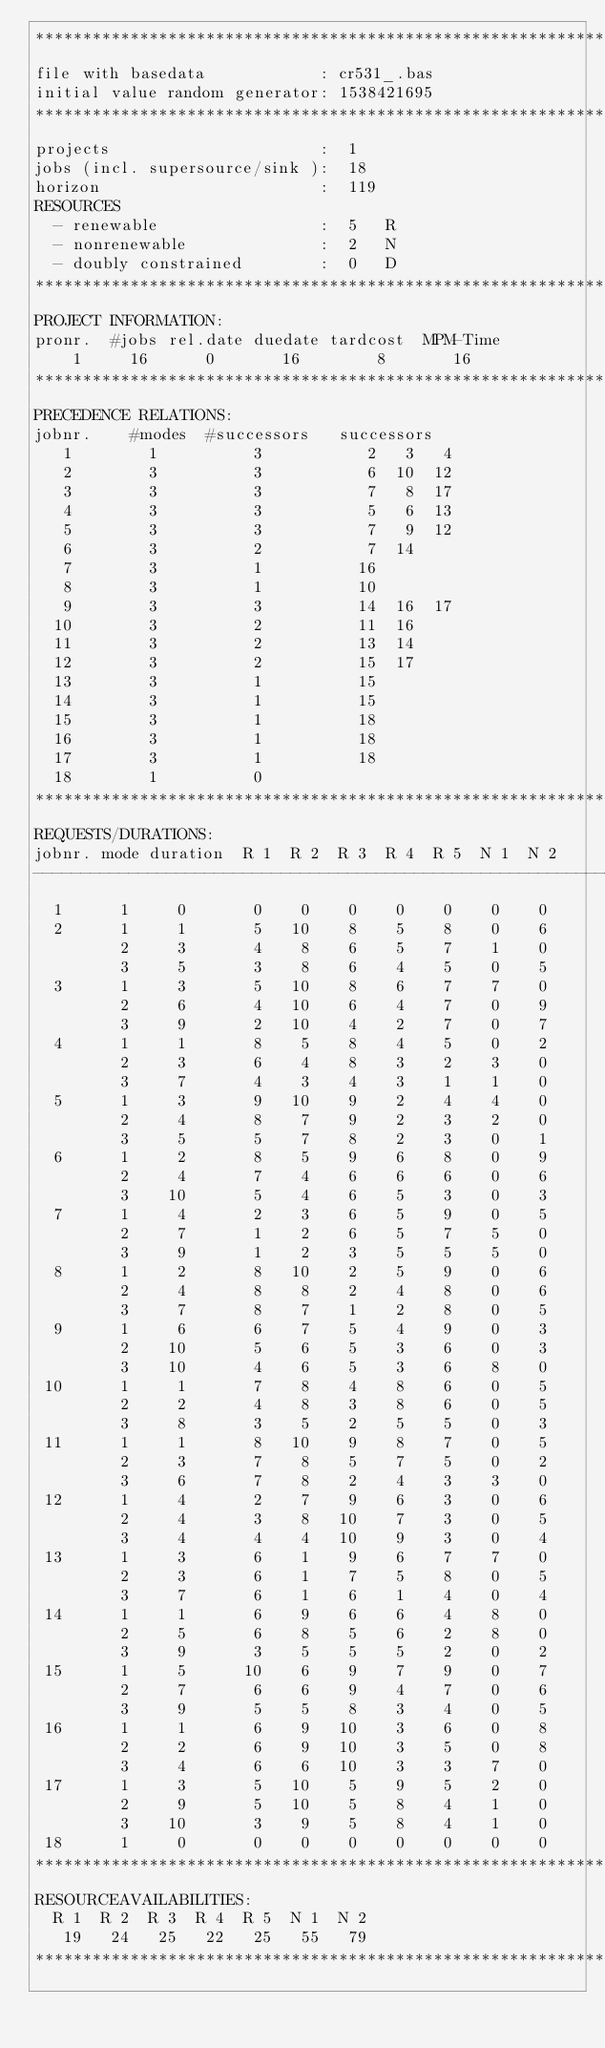Convert code to text. <code><loc_0><loc_0><loc_500><loc_500><_ObjectiveC_>************************************************************************
file with basedata            : cr531_.bas
initial value random generator: 1538421695
************************************************************************
projects                      :  1
jobs (incl. supersource/sink ):  18
horizon                       :  119
RESOURCES
  - renewable                 :  5   R
  - nonrenewable              :  2   N
  - doubly constrained        :  0   D
************************************************************************
PROJECT INFORMATION:
pronr.  #jobs rel.date duedate tardcost  MPM-Time
    1     16      0       16        8       16
************************************************************************
PRECEDENCE RELATIONS:
jobnr.    #modes  #successors   successors
   1        1          3           2   3   4
   2        3          3           6  10  12
   3        3          3           7   8  17
   4        3          3           5   6  13
   5        3          3           7   9  12
   6        3          2           7  14
   7        3          1          16
   8        3          1          10
   9        3          3          14  16  17
  10        3          2          11  16
  11        3          2          13  14
  12        3          2          15  17
  13        3          1          15
  14        3          1          15
  15        3          1          18
  16        3          1          18
  17        3          1          18
  18        1          0        
************************************************************************
REQUESTS/DURATIONS:
jobnr. mode duration  R 1  R 2  R 3  R 4  R 5  N 1  N 2
------------------------------------------------------------------------
  1      1     0       0    0    0    0    0    0    0
  2      1     1       5   10    8    5    8    0    6
         2     3       4    8    6    5    7    1    0
         3     5       3    8    6    4    5    0    5
  3      1     3       5   10    8    6    7    7    0
         2     6       4   10    6    4    7    0    9
         3     9       2   10    4    2    7    0    7
  4      1     1       8    5    8    4    5    0    2
         2     3       6    4    8    3    2    3    0
         3     7       4    3    4    3    1    1    0
  5      1     3       9   10    9    2    4    4    0
         2     4       8    7    9    2    3    2    0
         3     5       5    7    8    2    3    0    1
  6      1     2       8    5    9    6    8    0    9
         2     4       7    4    6    6    6    0    6
         3    10       5    4    6    5    3    0    3
  7      1     4       2    3    6    5    9    0    5
         2     7       1    2    6    5    7    5    0
         3     9       1    2    3    5    5    5    0
  8      1     2       8   10    2    5    9    0    6
         2     4       8    8    2    4    8    0    6
         3     7       8    7    1    2    8    0    5
  9      1     6       6    7    5    4    9    0    3
         2    10       5    6    5    3    6    0    3
         3    10       4    6    5    3    6    8    0
 10      1     1       7    8    4    8    6    0    5
         2     2       4    8    3    8    6    0    5
         3     8       3    5    2    5    5    0    3
 11      1     1       8   10    9    8    7    0    5
         2     3       7    8    5    7    5    0    2
         3     6       7    8    2    4    3    3    0
 12      1     4       2    7    9    6    3    0    6
         2     4       3    8   10    7    3    0    5
         3     4       4    4   10    9    3    0    4
 13      1     3       6    1    9    6    7    7    0
         2     3       6    1    7    5    8    0    5
         3     7       6    1    6    1    4    0    4
 14      1     1       6    9    6    6    4    8    0
         2     5       6    8    5    6    2    8    0
         3     9       3    5    5    5    2    0    2
 15      1     5      10    6    9    7    9    0    7
         2     7       6    6    9    4    7    0    6
         3     9       5    5    8    3    4    0    5
 16      1     1       6    9   10    3    6    0    8
         2     2       6    9   10    3    5    0    8
         3     4       6    6   10    3    3    7    0
 17      1     3       5   10    5    9    5    2    0
         2     9       5   10    5    8    4    1    0
         3    10       3    9    5    8    4    1    0
 18      1     0       0    0    0    0    0    0    0
************************************************************************
RESOURCEAVAILABILITIES:
  R 1  R 2  R 3  R 4  R 5  N 1  N 2
   19   24   25   22   25   55   79
************************************************************************
</code> 